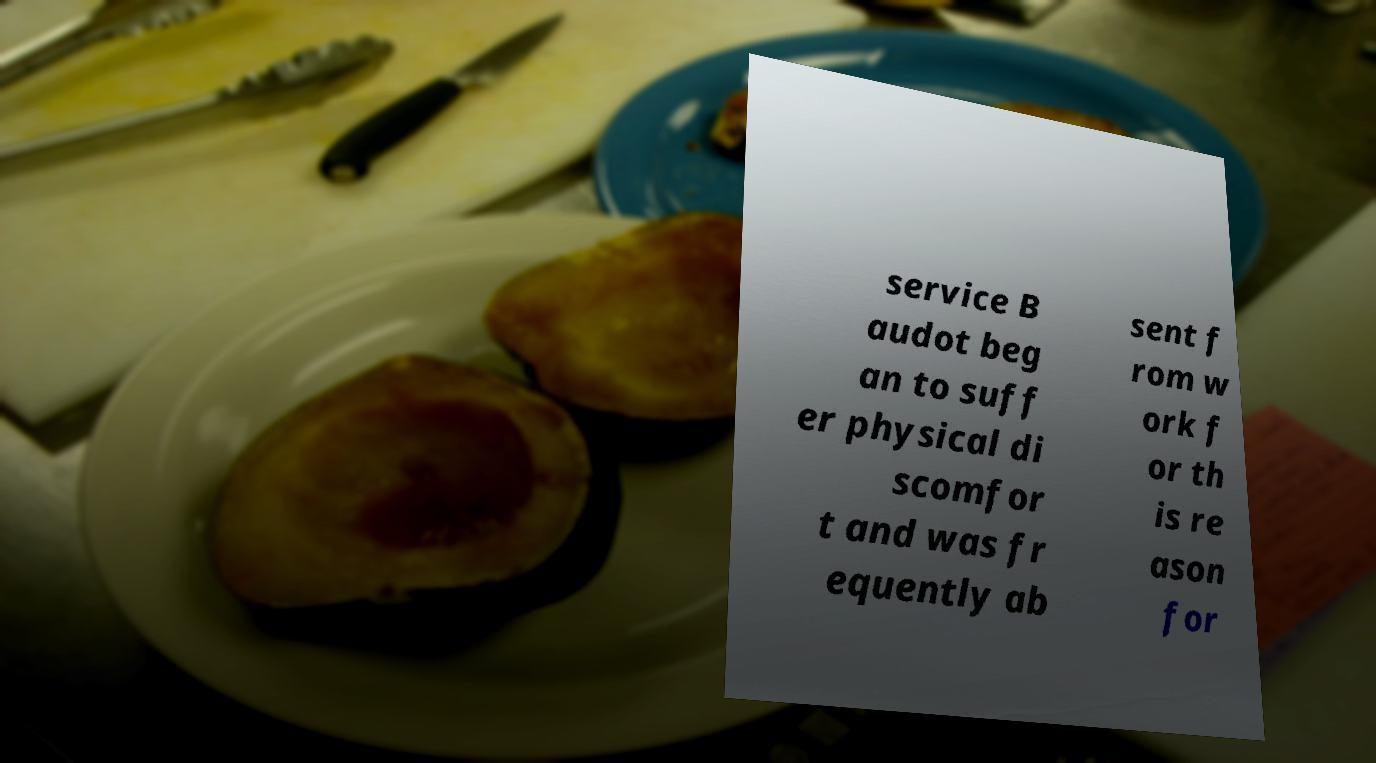Can you accurately transcribe the text from the provided image for me? service B audot beg an to suff er physical di scomfor t and was fr equently ab sent f rom w ork f or th is re ason for 